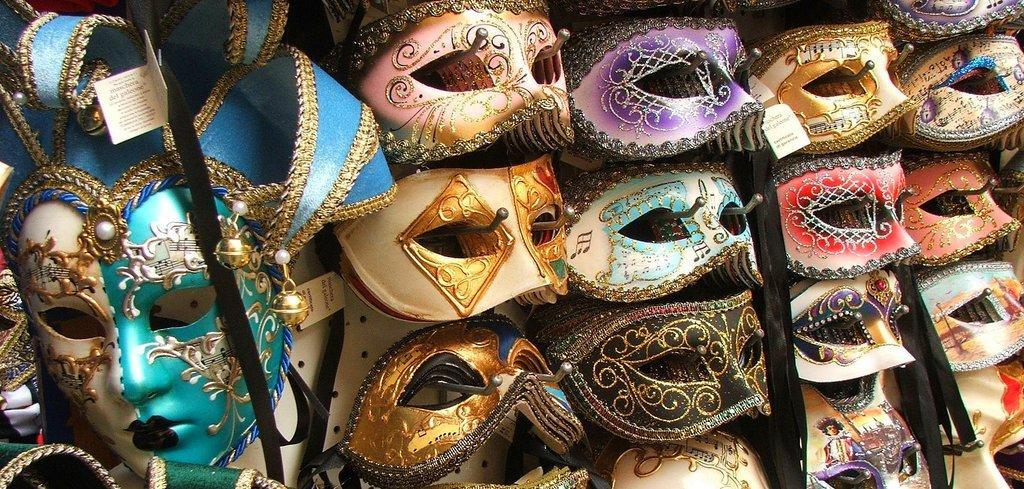How would you summarize this image in a sentence or two? In this image I can see few masks which are green, white, gold, cream, black, red, pink, violet and blue in color. I can see few papers, a white colored surface and few black colored belts. 